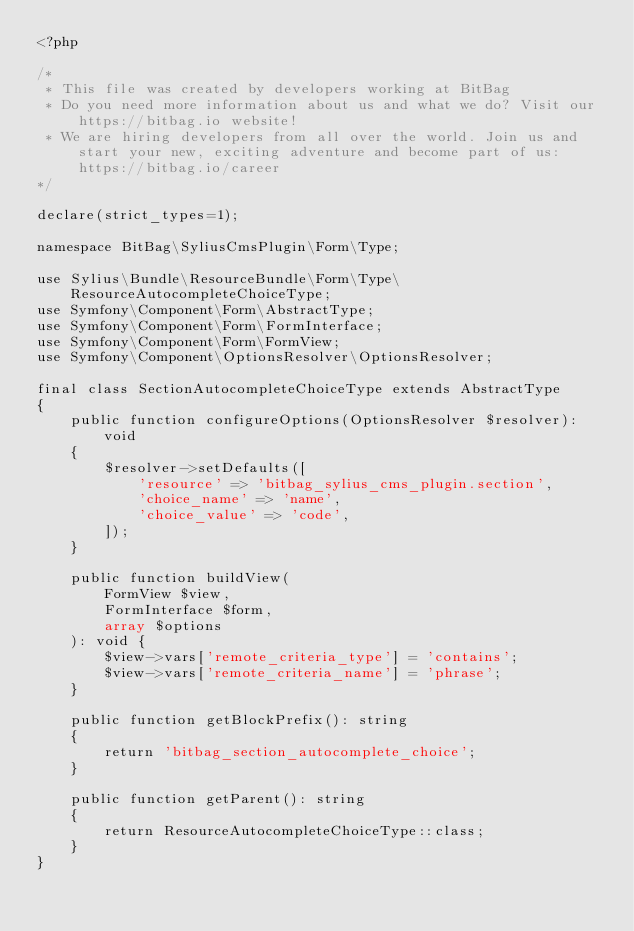Convert code to text. <code><loc_0><loc_0><loc_500><loc_500><_PHP_><?php

/*
 * This file was created by developers working at BitBag
 * Do you need more information about us and what we do? Visit our https://bitbag.io website!
 * We are hiring developers from all over the world. Join us and start your new, exciting adventure and become part of us: https://bitbag.io/career
*/

declare(strict_types=1);

namespace BitBag\SyliusCmsPlugin\Form\Type;

use Sylius\Bundle\ResourceBundle\Form\Type\ResourceAutocompleteChoiceType;
use Symfony\Component\Form\AbstractType;
use Symfony\Component\Form\FormInterface;
use Symfony\Component\Form\FormView;
use Symfony\Component\OptionsResolver\OptionsResolver;

final class SectionAutocompleteChoiceType extends AbstractType
{
    public function configureOptions(OptionsResolver $resolver): void
    {
        $resolver->setDefaults([
            'resource' => 'bitbag_sylius_cms_plugin.section',
            'choice_name' => 'name',
            'choice_value' => 'code',
        ]);
    }

    public function buildView(
        FormView $view,
        FormInterface $form,
        array $options
    ): void {
        $view->vars['remote_criteria_type'] = 'contains';
        $view->vars['remote_criteria_name'] = 'phrase';
    }

    public function getBlockPrefix(): string
    {
        return 'bitbag_section_autocomplete_choice';
    }

    public function getParent(): string
    {
        return ResourceAutocompleteChoiceType::class;
    }
}
</code> 